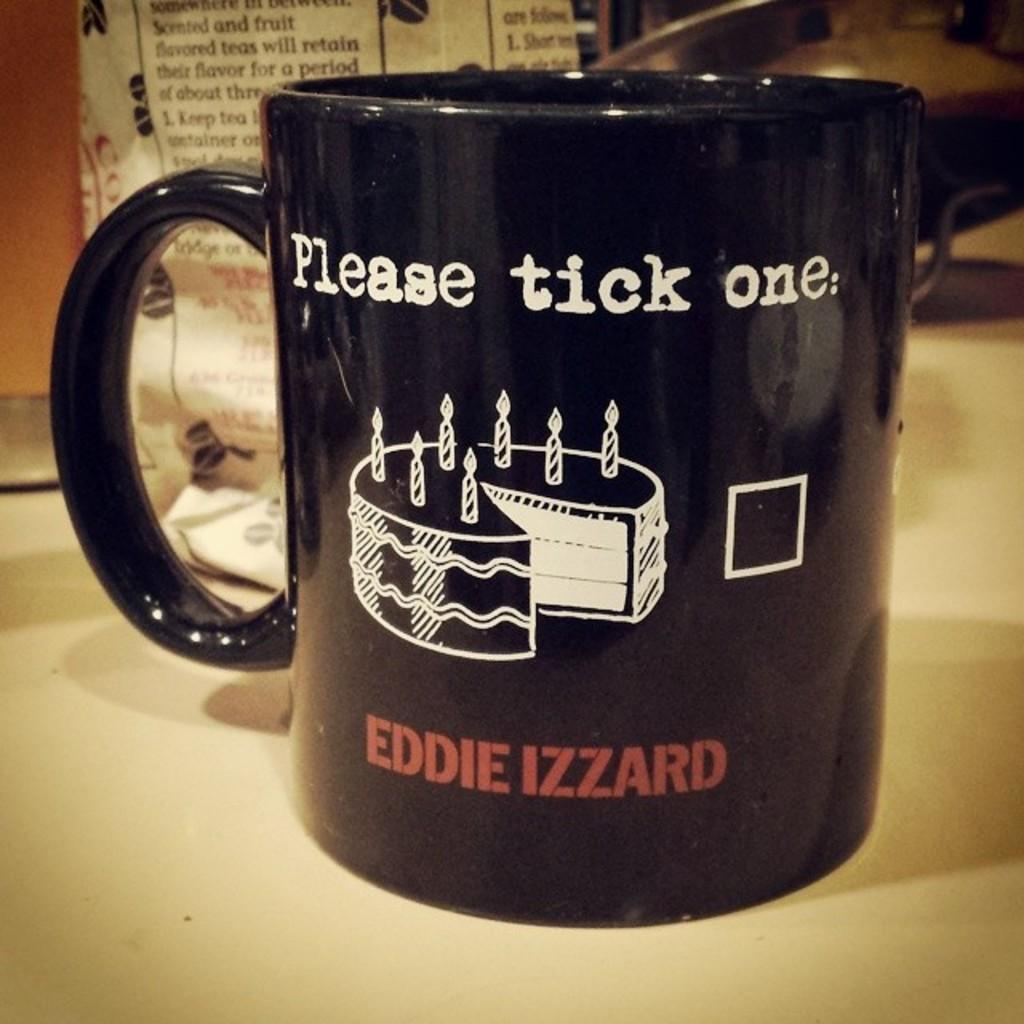<image>
Give a short and clear explanation of the subsequent image. a black mug featuring a cake and the name Eddie Izzard 